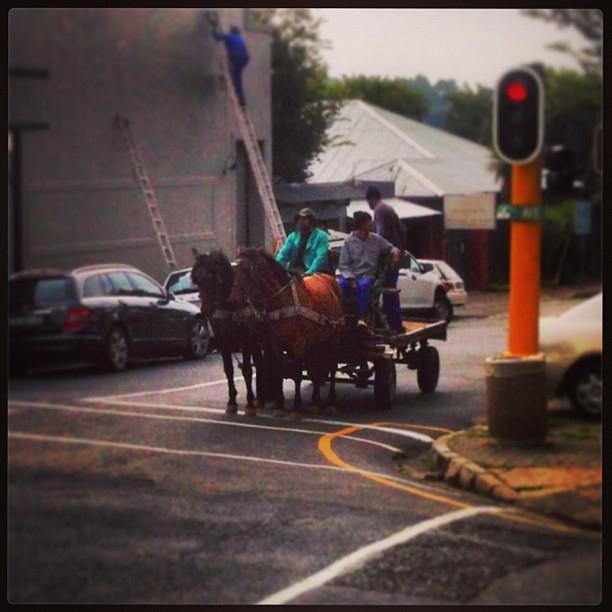How many horses are there?
Give a very brief answer. 2. How many people are in the photo?
Give a very brief answer. 2. How many cars can you see?
Give a very brief answer. 3. How many giraffes are there?
Give a very brief answer. 0. 